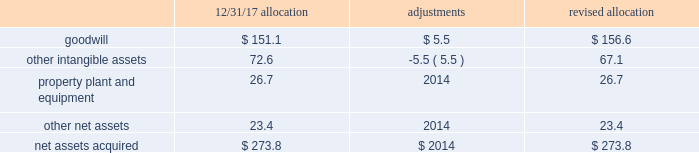Sacramento container acquisition in october 2017 , pca acquired substantially all of the assets of sacramento container corporation , and 100% ( 100 % ) of the membership interests of northern sheets , llc and central california sheets , llc ( collectively referred to as 201csacramento container 201d ) for a purchase price of $ 274 million , including working capital adjustments .
Funding for the acquisition came from available cash on hand .
Assets acquired include full-line corrugated products and sheet feeder operations in both mcclellan , california and kingsburg , california .
Sacramento container provides packaging solutions to customers serving portions of california 2019s strong agricultural market .
Sacramento container 2019s financial results are included in the packaging segment from the date of acquisition .
The company accounted for the sacramento container acquisition using the acquisition method of accounting in accordance with asc 805 , business combinations .
The total purchase price has been allocated to tangible and intangible assets acquired and liabilities assumed based on respective fair values , as follows ( dollars in millions ) : .
During the second quarter ended june 30 , 2018 , we made a $ 5.5 million net adjustment based on the final valuation of the intangible assets .
We recorded the adjustment as a decrease to other intangible assets with an offset to goodwill .
Goodwill is calculated as the excess of the purchase price over the fair value of the net assets acquired .
Among the factors that contributed to the recognition of goodwill were sacramento container 2019s commitment to continuous improvement and regional synergies , as well as the expected increases in pca 2019s containerboard integration levels .
Goodwill is deductible for tax purposes .
Other intangible assets , primarily customer relationships , were assigned an estimated weighted average useful life of 9.6 years .
Property , plant and equipment were assigned estimated useful lives ranging from one to 13 years. .
For the revised total purchase price allocation , goodwill was what percentage of net assets acquired? 
Computations: (156.6 / 273.8)
Answer: 0.57195. 